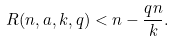Convert formula to latex. <formula><loc_0><loc_0><loc_500><loc_500>R ( n , a , k , q ) < n - \frac { q n } k .</formula> 